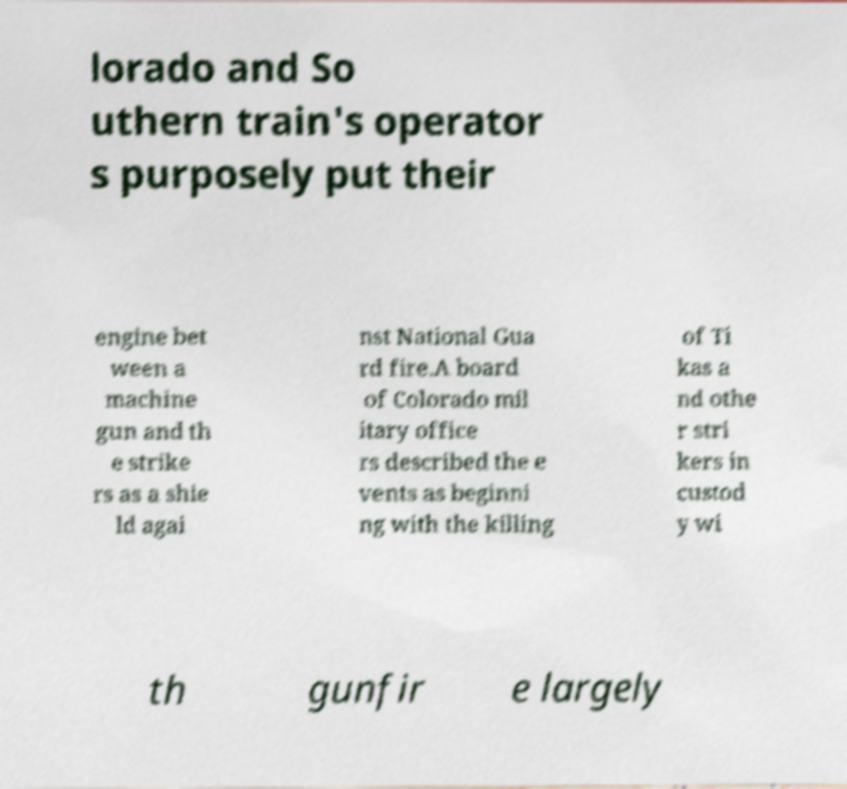Please identify and transcribe the text found in this image. lorado and So uthern train's operator s purposely put their engine bet ween a machine gun and th e strike rs as a shie ld agai nst National Gua rd fire.A board of Colorado mil itary office rs described the e vents as beginni ng with the killing of Ti kas a nd othe r stri kers in custod y wi th gunfir e largely 